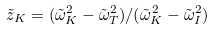Convert formula to latex. <formula><loc_0><loc_0><loc_500><loc_500>\tilde { z } _ { K } = ( \tilde { \omega } _ { K } ^ { 2 } - \tilde { \omega } _ { T } ^ { 2 } ) / ( \tilde { \omega } _ { K } ^ { 2 } - \tilde { \omega } _ { I } ^ { 2 } )</formula> 